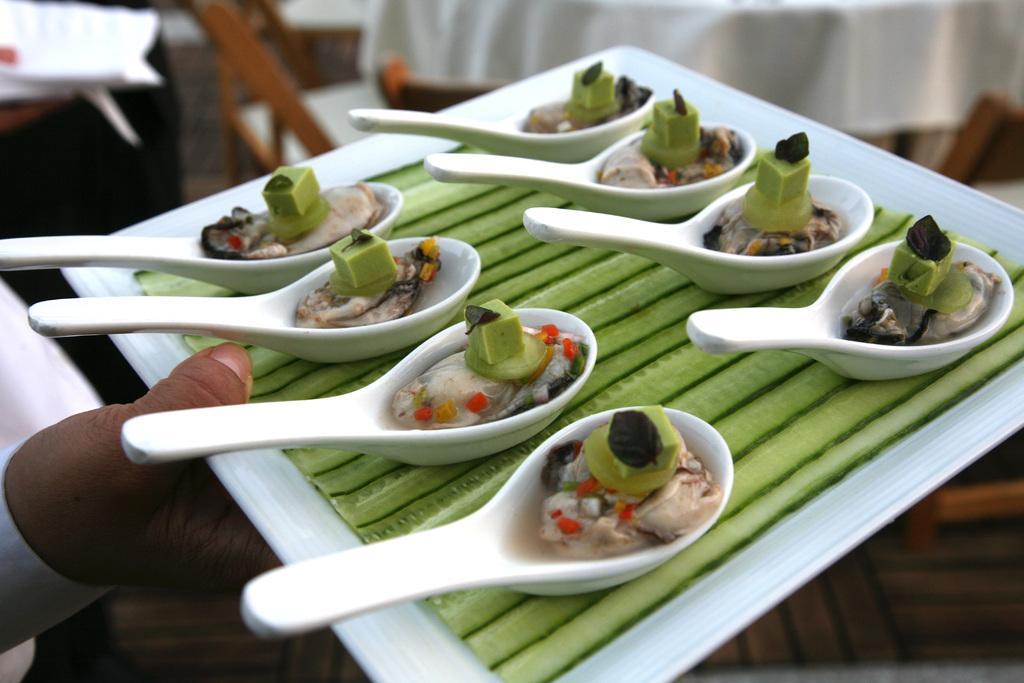Please provide a concise description of this image. In this picture we can see a person holding a tray with spoons and food. In the background it is blurry and we can see white cloth. 